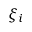Convert formula to latex. <formula><loc_0><loc_0><loc_500><loc_500>\xi _ { i }</formula> 